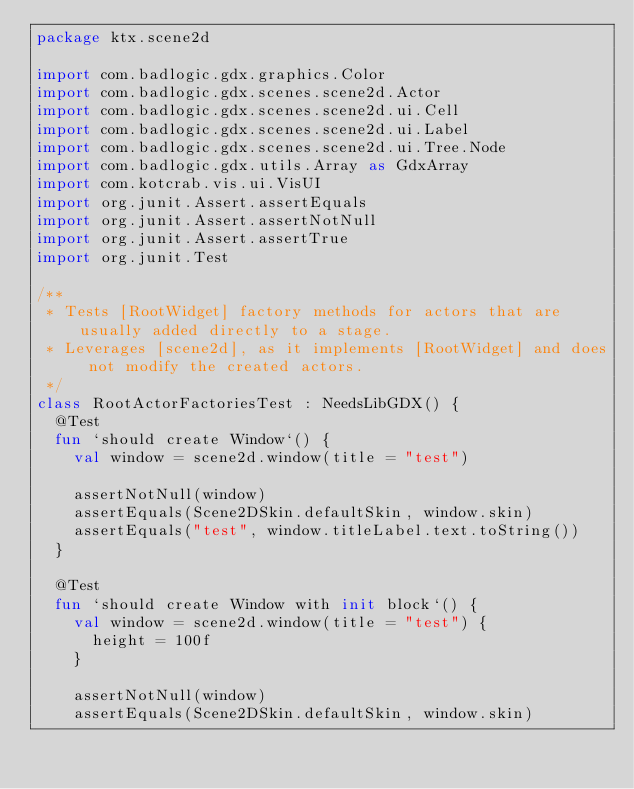<code> <loc_0><loc_0><loc_500><loc_500><_Kotlin_>package ktx.scene2d

import com.badlogic.gdx.graphics.Color
import com.badlogic.gdx.scenes.scene2d.Actor
import com.badlogic.gdx.scenes.scene2d.ui.Cell
import com.badlogic.gdx.scenes.scene2d.ui.Label
import com.badlogic.gdx.scenes.scene2d.ui.Tree.Node
import com.badlogic.gdx.utils.Array as GdxArray
import com.kotcrab.vis.ui.VisUI
import org.junit.Assert.assertEquals
import org.junit.Assert.assertNotNull
import org.junit.Assert.assertTrue
import org.junit.Test

/**
 * Tests [RootWidget] factory methods for actors that are usually added directly to a stage.
 * Leverages [scene2d], as it implements [RootWidget] and does not modify the created actors.
 */
class RootActorFactoriesTest : NeedsLibGDX() {
  @Test
  fun `should create Window`() {
    val window = scene2d.window(title = "test")

    assertNotNull(window)
    assertEquals(Scene2DSkin.defaultSkin, window.skin)
    assertEquals("test", window.titleLabel.text.toString())
  }

  @Test
  fun `should create Window with init block`() {
    val window = scene2d.window(title = "test") {
      height = 100f
    }

    assertNotNull(window)
    assertEquals(Scene2DSkin.defaultSkin, window.skin)</code> 